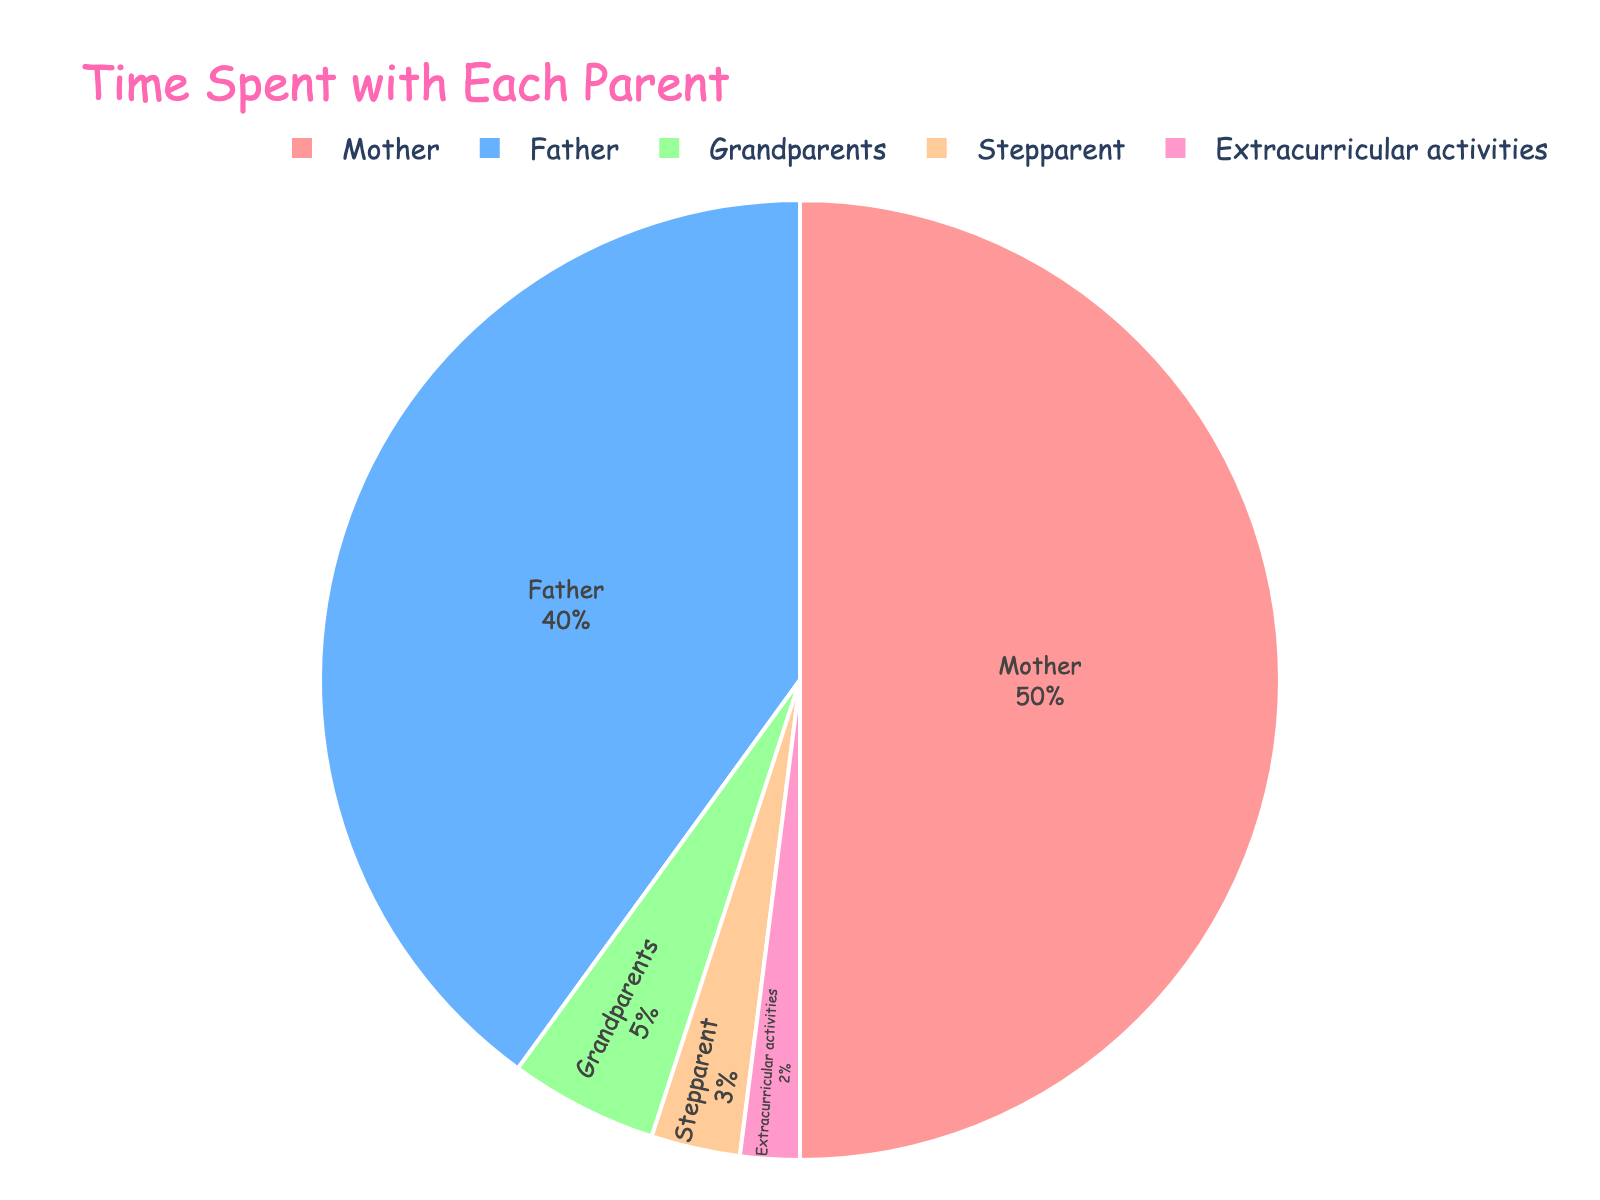Which parent does the teenager spend the most time with? The parent with the highest percentage on the pie chart is the mother, with 50%.
Answer: Mother What is the total percentage of time spent with both parents combined? The figure shows that the teenager spends 50% with the mother and 40% with the father, so adding these together gives 50% + 40% = 90%.
Answer: 90% How does the time spent with grandparents compare to the time spent with extracurricular activities? The chart shows that the teenager spends 5% of their time with grandparents and 2% with extracurricular activities. Since 5% is greater than 2%, more time is spent with grandparents.
Answer: More time with grandparents What is the proportion of time spent with stepparent relative to the time spent with father? The figure shows that 3% of time is with the stepparent and 40% with the father. The ratio is 3% / 40% = 0.075, or 7.5%.
Answer: 7.5% Is the time spent with grandparents more or less than the sum of time spent with stepparent and extracurricular activities? The chart indicates 5% with grandparents, 3% with stepparent, and 2% with extracurricular activities. Adding stepparent and extracurricular activities gives 3% + 2% = 5%. Since 5% (grandparents) is equal to the sum of 3% and 2%, the time is the same.
Answer: Equal What is the difference between the time spent with the mother and father? According to the figure, time with the mother is 50% and time with the father is 40%. The difference is 50% - 40% = 10%.
Answer: 10% Which category represents the smallest portion of the time spent? The smallest segment of the pie chart is for extracurricular activities, which is 2%.
Answer: Extracurricular activities If the teenager decides to reduce the time with the mother and equally distribute it to other categories, what would be the new time spent with the father assuming nothing else changes? If part of the mother's time is redistributed, we assume the father's portion would increase. Originally mother has 50% and father 40%. If 10% is taken from the mother and spread evenly among the 5 categories, father gains 2% (10% / 5 categories). Thus, new father is 40% + 2% = 42%.
Answer: 42% 